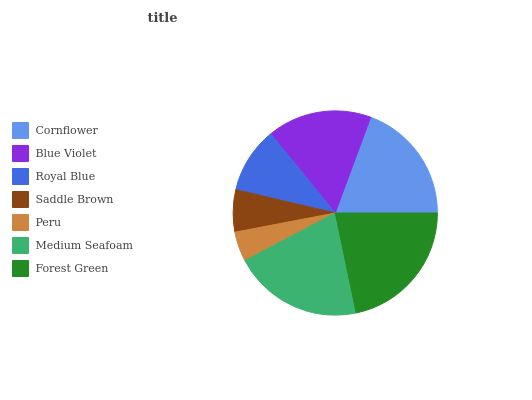Is Peru the minimum?
Answer yes or no. Yes. Is Forest Green the maximum?
Answer yes or no. Yes. Is Blue Violet the minimum?
Answer yes or no. No. Is Blue Violet the maximum?
Answer yes or no. No. Is Cornflower greater than Blue Violet?
Answer yes or no. Yes. Is Blue Violet less than Cornflower?
Answer yes or no. Yes. Is Blue Violet greater than Cornflower?
Answer yes or no. No. Is Cornflower less than Blue Violet?
Answer yes or no. No. Is Blue Violet the high median?
Answer yes or no. Yes. Is Blue Violet the low median?
Answer yes or no. Yes. Is Medium Seafoam the high median?
Answer yes or no. No. Is Peru the low median?
Answer yes or no. No. 